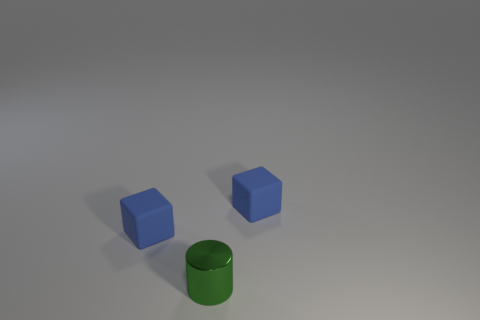Add 2 green cylinders. How many objects exist? 5 Subtract all cylinders. How many objects are left? 2 Add 2 tiny things. How many tiny things are left? 5 Add 2 small blue rubber things. How many small blue rubber things exist? 4 Subtract 0 green spheres. How many objects are left? 3 Subtract all big yellow shiny spheres. Subtract all tiny green metal cylinders. How many objects are left? 2 